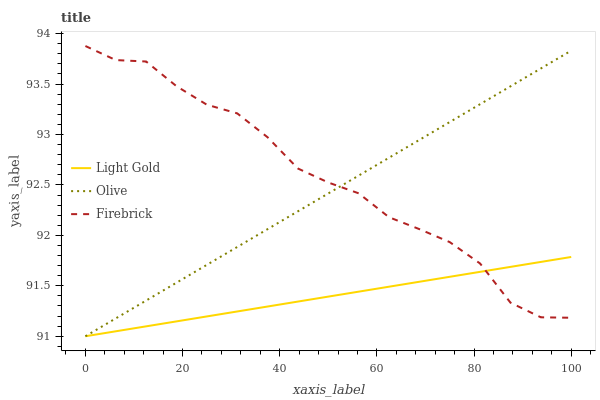Does Light Gold have the minimum area under the curve?
Answer yes or no. Yes. Does Firebrick have the maximum area under the curve?
Answer yes or no. Yes. Does Firebrick have the minimum area under the curve?
Answer yes or no. No. Does Light Gold have the maximum area under the curve?
Answer yes or no. No. Is Olive the smoothest?
Answer yes or no. Yes. Is Firebrick the roughest?
Answer yes or no. Yes. Is Light Gold the smoothest?
Answer yes or no. No. Is Light Gold the roughest?
Answer yes or no. No. Does Olive have the lowest value?
Answer yes or no. Yes. Does Firebrick have the lowest value?
Answer yes or no. No. Does Firebrick have the highest value?
Answer yes or no. Yes. Does Light Gold have the highest value?
Answer yes or no. No. Does Olive intersect Firebrick?
Answer yes or no. Yes. Is Olive less than Firebrick?
Answer yes or no. No. Is Olive greater than Firebrick?
Answer yes or no. No. 